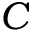<formula> <loc_0><loc_0><loc_500><loc_500>C</formula> 